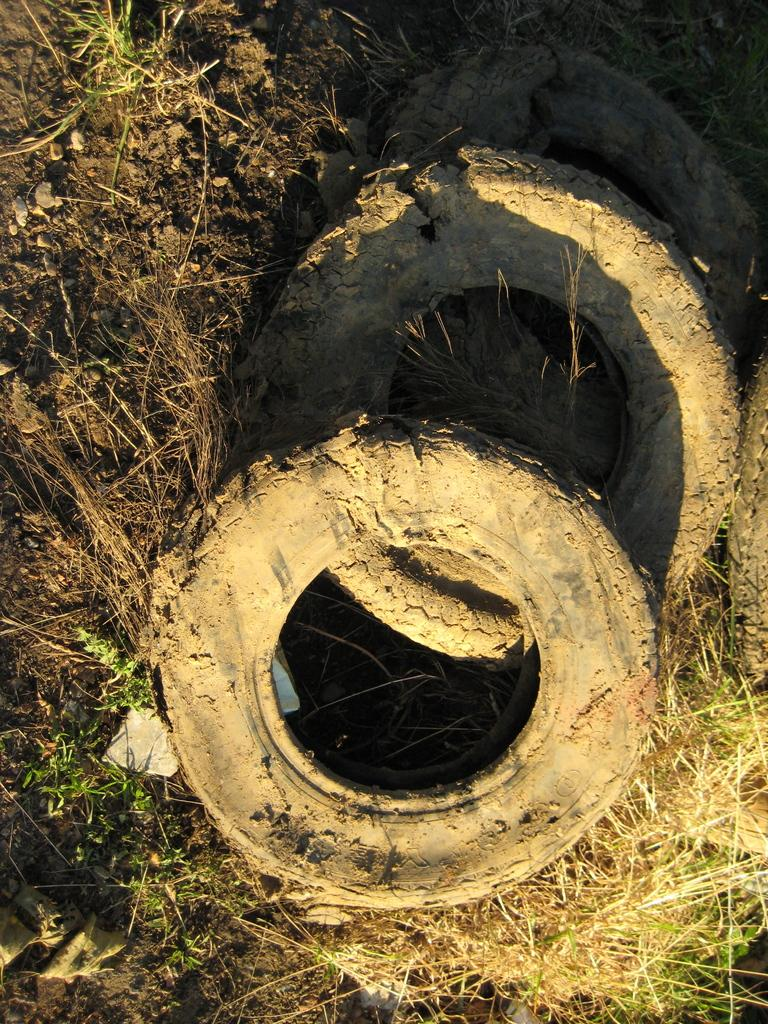What objects are present in the image? There are two worn tires in the image. Where are the tires located? The tires are on the grass land. What is the condition of the tires? The tires are covered in mud. What position does the cub hold in the image? There is no cub present in the image. 